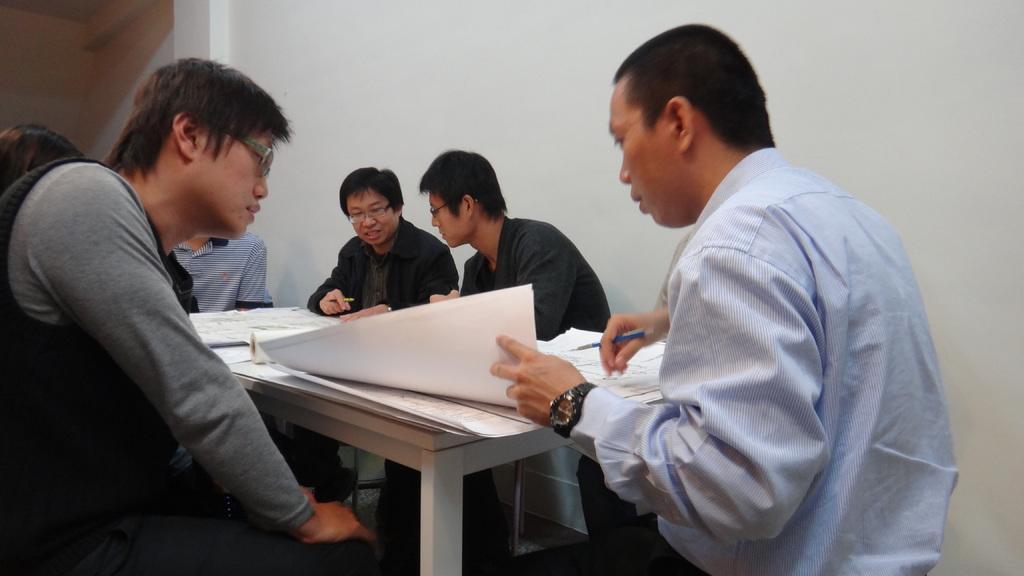Describe this image in one or two sentences. In this image In the middle there is a table on that there are many chart , around that there are some people sitting. On the right there is a man he wear shirt and watch he is holding a pen. On the left there is a man he is staring at chat. In the background there is a wall. 